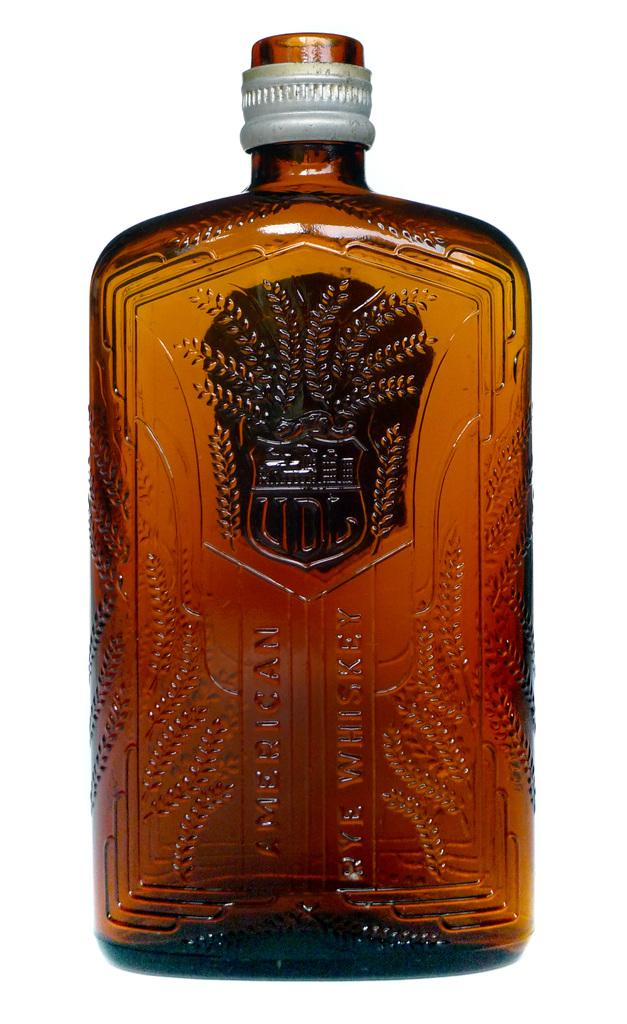What type of alcoholic beverage is in the image? There is a whisky bottle in the image. What color is the whisky bottle? The whisky bottle is brown in color. What type of whiskey is in the bottle? The words "American Rye Whiskey" are written on the bottle. What material is used for the seal on the bottle cap? There is a steel seal on the bottle cap. Can you see any fairies interacting with the whisky bottle in the image? There are no fairies present in the image. What is the self-awareness level of the whisky bottle in the image? The whisky bottle is an inanimate object and does not have self-awareness. 